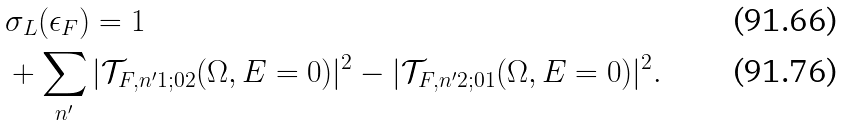Convert formula to latex. <formula><loc_0><loc_0><loc_500><loc_500>& \sigma _ { L } ( \epsilon _ { F } ) = 1 \\ & + \sum _ { n ^ { \prime } } | \mathcal { T } _ { F , n ^ { \prime } 1 ; 0 2 } ( \Omega , E = 0 ) | ^ { 2 } - | \mathcal { T } _ { F , n ^ { \prime } 2 ; 0 1 } ( \Omega , E = 0 ) | ^ { 2 } .</formula> 